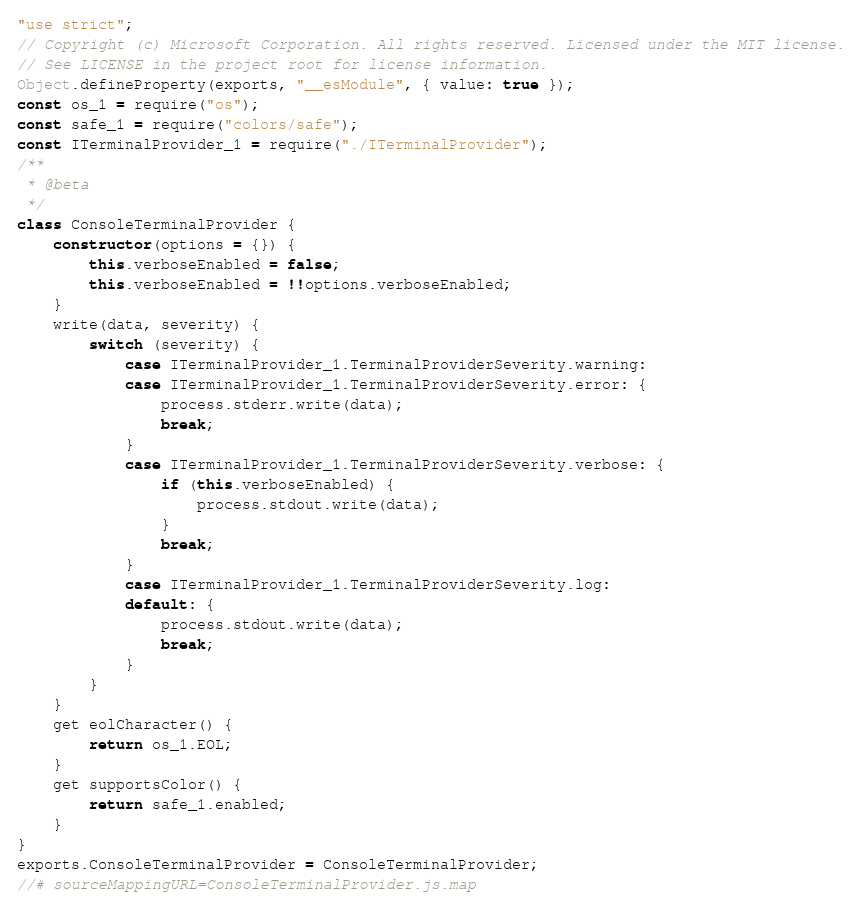Convert code to text. <code><loc_0><loc_0><loc_500><loc_500><_JavaScript_>"use strict";
// Copyright (c) Microsoft Corporation. All rights reserved. Licensed under the MIT license.
// See LICENSE in the project root for license information.
Object.defineProperty(exports, "__esModule", { value: true });
const os_1 = require("os");
const safe_1 = require("colors/safe");
const ITerminalProvider_1 = require("./ITerminalProvider");
/**
 * @beta
 */
class ConsoleTerminalProvider {
    constructor(options = {}) {
        this.verboseEnabled = false;
        this.verboseEnabled = !!options.verboseEnabled;
    }
    write(data, severity) {
        switch (severity) {
            case ITerminalProvider_1.TerminalProviderSeverity.warning:
            case ITerminalProvider_1.TerminalProviderSeverity.error: {
                process.stderr.write(data);
                break;
            }
            case ITerminalProvider_1.TerminalProviderSeverity.verbose: {
                if (this.verboseEnabled) {
                    process.stdout.write(data);
                }
                break;
            }
            case ITerminalProvider_1.TerminalProviderSeverity.log:
            default: {
                process.stdout.write(data);
                break;
            }
        }
    }
    get eolCharacter() {
        return os_1.EOL;
    }
    get supportsColor() {
        return safe_1.enabled;
    }
}
exports.ConsoleTerminalProvider = ConsoleTerminalProvider;
//# sourceMappingURL=ConsoleTerminalProvider.js.map</code> 